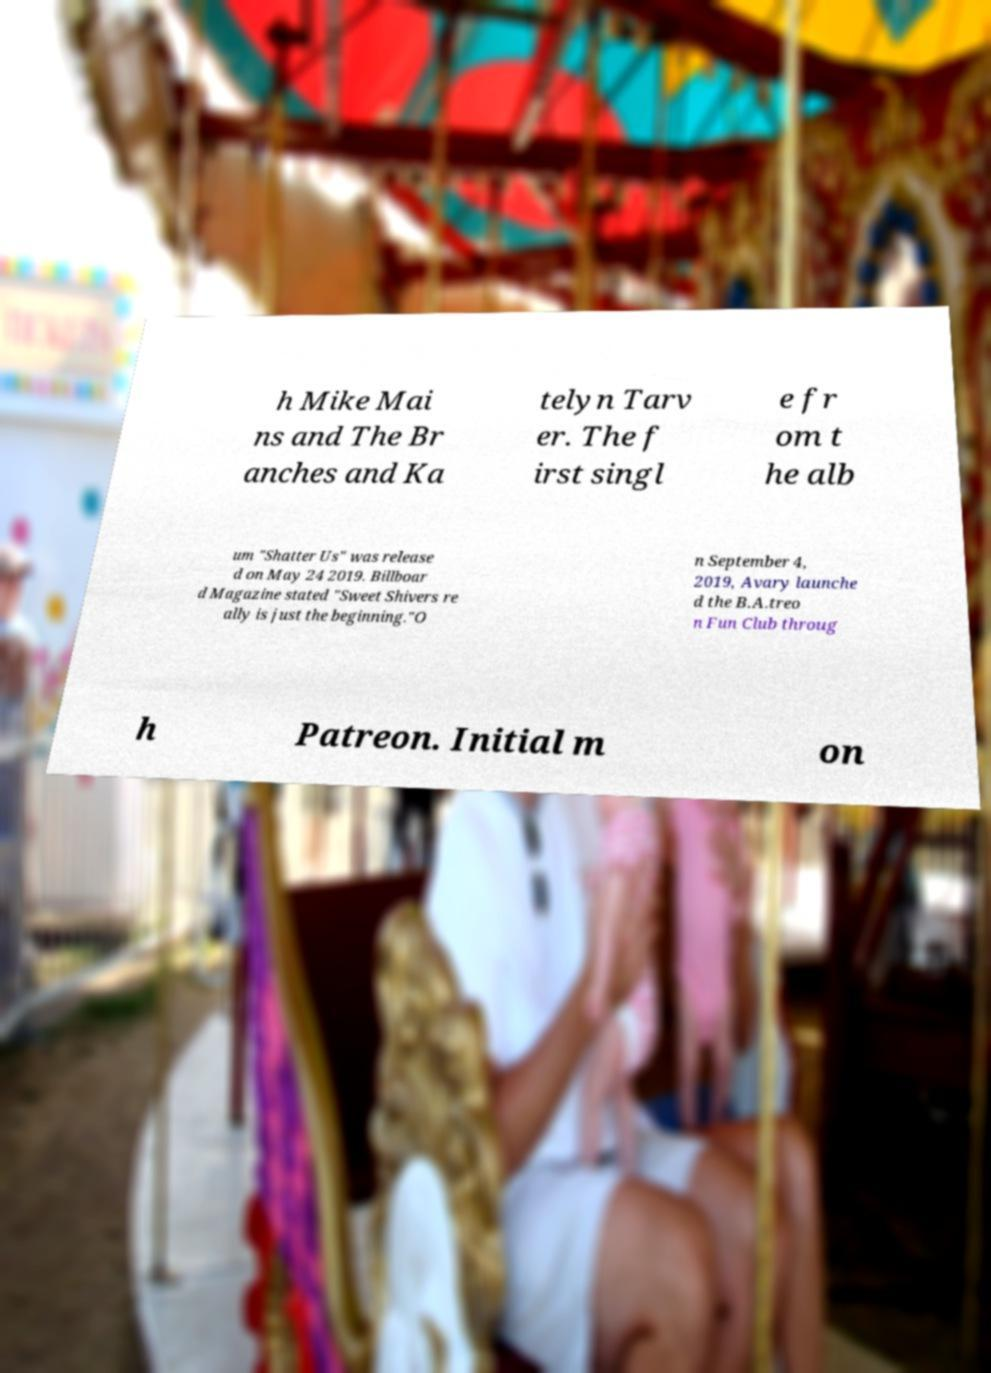There's text embedded in this image that I need extracted. Can you transcribe it verbatim? h Mike Mai ns and The Br anches and Ka telyn Tarv er. The f irst singl e fr om t he alb um "Shatter Us" was release d on May 24 2019. Billboar d Magazine stated "Sweet Shivers re ally is just the beginning."O n September 4, 2019, Avary launche d the B.A.treo n Fun Club throug h Patreon. Initial m on 